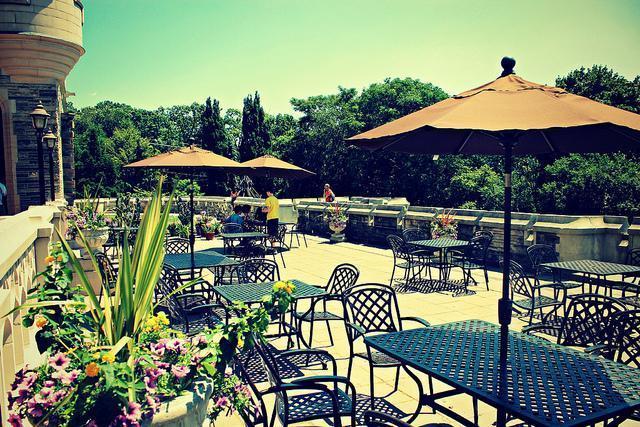How many chairs can you see?
Give a very brief answer. 4. How many potted plants can you see?
Give a very brief answer. 2. 